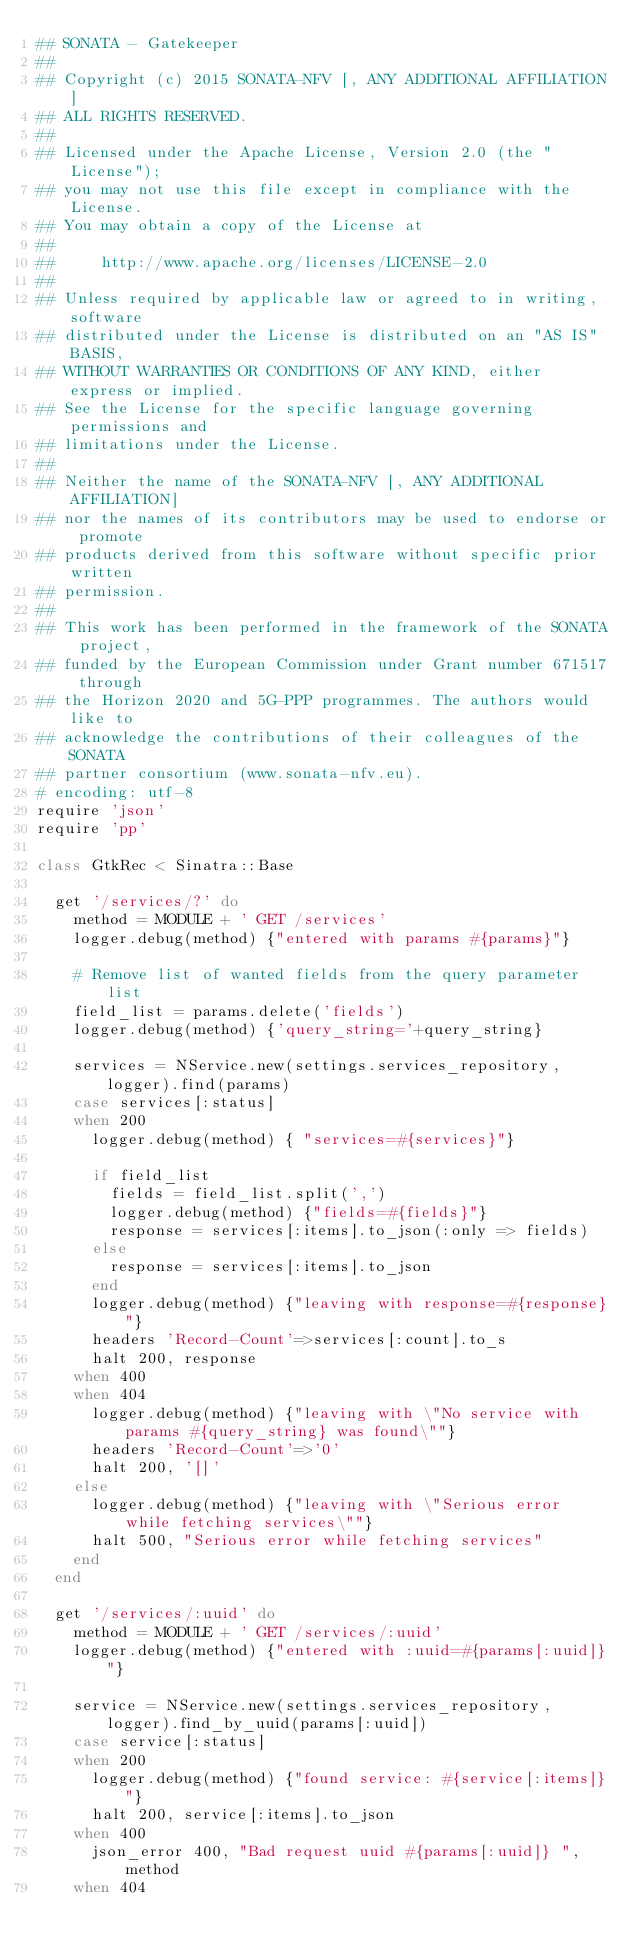<code> <loc_0><loc_0><loc_500><loc_500><_Ruby_>## SONATA - Gatekeeper
##
## Copyright (c) 2015 SONATA-NFV [, ANY ADDITIONAL AFFILIATION]
## ALL RIGHTS RESERVED.
## 
## Licensed under the Apache License, Version 2.0 (the "License");
## you may not use this file except in compliance with the License.
## You may obtain a copy of the License at
## 
##     http://www.apache.org/licenses/LICENSE-2.0
## 
## Unless required by applicable law or agreed to in writing, software
## distributed under the License is distributed on an "AS IS" BASIS,
## WITHOUT WARRANTIES OR CONDITIONS OF ANY KIND, either express or implied.
## See the License for the specific language governing permissions and
## limitations under the License.
## 
## Neither the name of the SONATA-NFV [, ANY ADDITIONAL AFFILIATION]
## nor the names of its contributors may be used to endorse or promote 
## products derived from this software without specific prior written 
## permission.
## 
## This work has been performed in the framework of the SONATA project,
## funded by the European Commission under Grant number 671517 through 
## the Horizon 2020 and 5G-PPP programmes. The authors would like to 
## acknowledge the contributions of their colleagues of the SONATA 
## partner consortium (www.sonata-nfv.eu).
# encoding: utf-8
require 'json' 
require 'pp'

class GtkRec < Sinatra::Base

  get '/services/?' do
    method = MODULE + ' GET /services'
    logger.debug(method) {"entered with params #{params}"}

    # Remove list of wanted fields from the query parameter list
    field_list = params.delete('fields')
    logger.debug(method) {'query_string='+query_string}
    
    services = NService.new(settings.services_repository, logger).find(params)
    case services[:status]
    when 200
      logger.debug(method) { "services=#{services}"}

      if field_list
        fields = field_list.split(',')
        logger.debug(method) {"fields=#{fields}"}
        response = services[:items].to_json(:only => fields)
      else
        response = services[:items].to_json
      end
      logger.debug(method) {"leaving with response=#{response}"}
      headers 'Record-Count'=>services[:count].to_s
      halt 200, response
    when 400
    when 404
      logger.debug(method) {"leaving with \"No service with params #{query_string} was found\""}
      headers 'Record-Count'=>'0'
      halt 200, '[]'
    else
      logger.debug(method) {"leaving with \"Serious error while fetching services\""}
      halt 500, "Serious error while fetching services"
    end
  end
  
  get '/services/:uuid' do
    method = MODULE + ' GET /services/:uuid'
    logger.debug(method) {"entered with :uuid=#{params[:uuid]}"}
    
    service = NService.new(settings.services_repository, logger).find_by_uuid(params[:uuid])
    case service[:status]
    when 200
      logger.debug(method) {"found service: #{service[:items]}"}
      halt 200, service[:items].to_json
    when 400
      json_error 400, "Bad request uuid #{params[:uuid]} ", method
    when 404</code> 